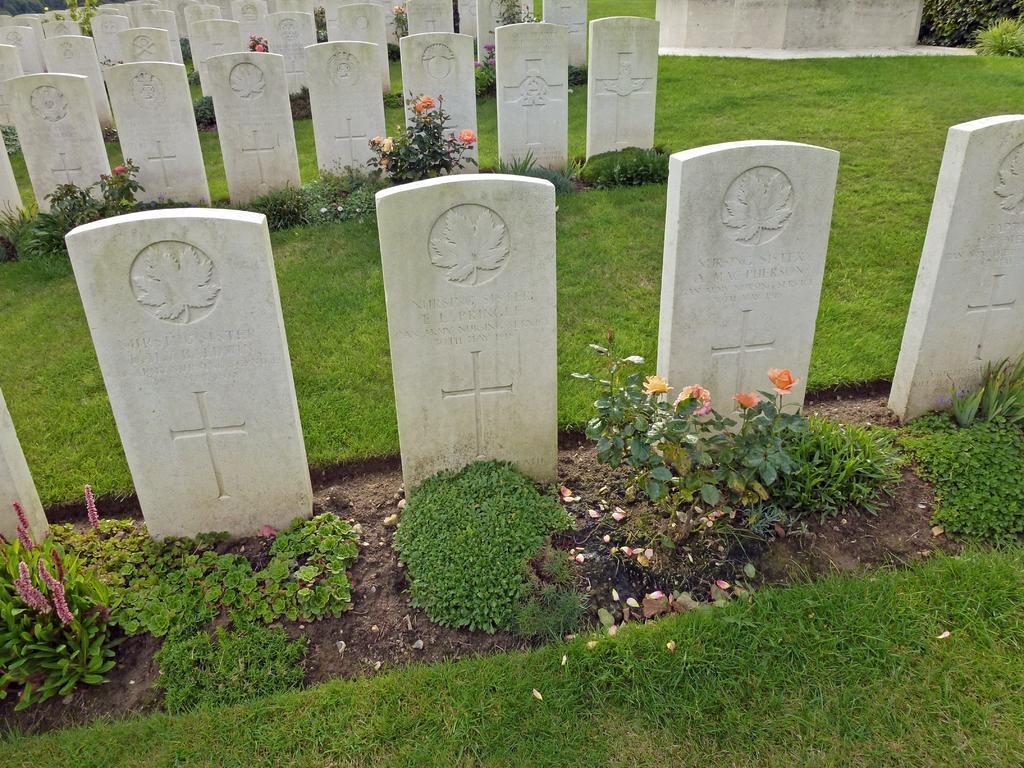In one or two sentences, can you explain what this image depicts? In this image I can see few cemeteries and I can also see few flowers in multi color and the grass is in green color. 